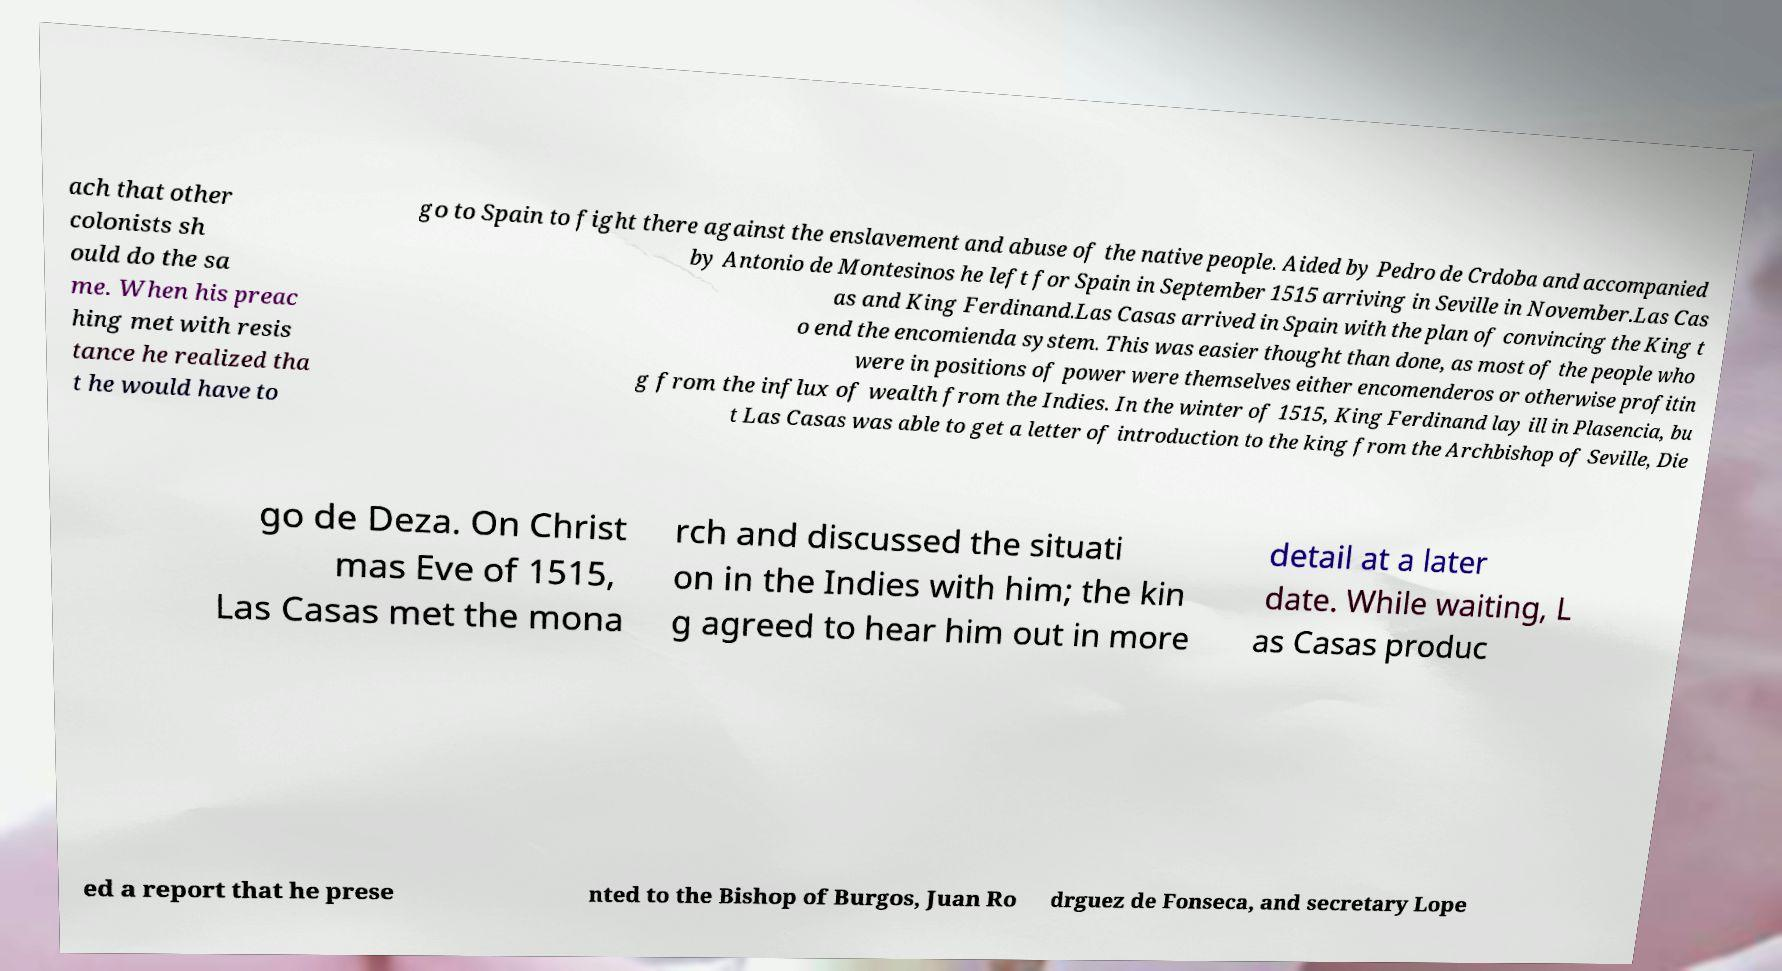What messages or text are displayed in this image? I need them in a readable, typed format. ach that other colonists sh ould do the sa me. When his preac hing met with resis tance he realized tha t he would have to go to Spain to fight there against the enslavement and abuse of the native people. Aided by Pedro de Crdoba and accompanied by Antonio de Montesinos he left for Spain in September 1515 arriving in Seville in November.Las Cas as and King Ferdinand.Las Casas arrived in Spain with the plan of convincing the King t o end the encomienda system. This was easier thought than done, as most of the people who were in positions of power were themselves either encomenderos or otherwise profitin g from the influx of wealth from the Indies. In the winter of 1515, King Ferdinand lay ill in Plasencia, bu t Las Casas was able to get a letter of introduction to the king from the Archbishop of Seville, Die go de Deza. On Christ mas Eve of 1515, Las Casas met the mona rch and discussed the situati on in the Indies with him; the kin g agreed to hear him out in more detail at a later date. While waiting, L as Casas produc ed a report that he prese nted to the Bishop of Burgos, Juan Ro drguez de Fonseca, and secretary Lope 